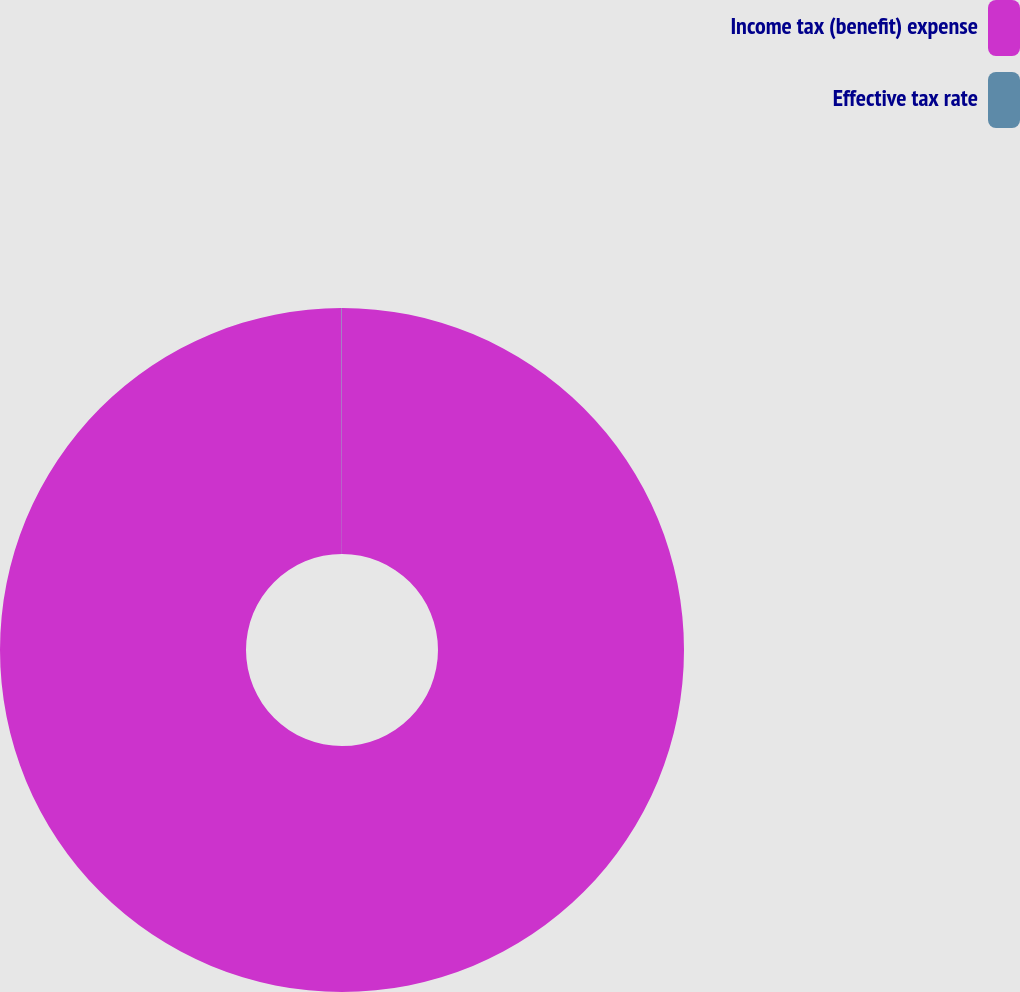<chart> <loc_0><loc_0><loc_500><loc_500><pie_chart><fcel>Income tax (benefit) expense<fcel>Effective tax rate<nl><fcel>99.98%<fcel>0.02%<nl></chart> 